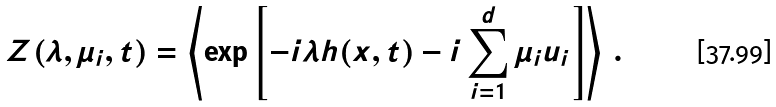Convert formula to latex. <formula><loc_0><loc_0><loc_500><loc_500>Z ( \lambda , \mu _ { i } , t ) = \left \langle \exp \left [ - i \lambda h ( { x } , t ) - i \sum _ { i = 1 } ^ { d } \mu _ { i } u _ { i } \right ] \right \rangle \, .</formula> 